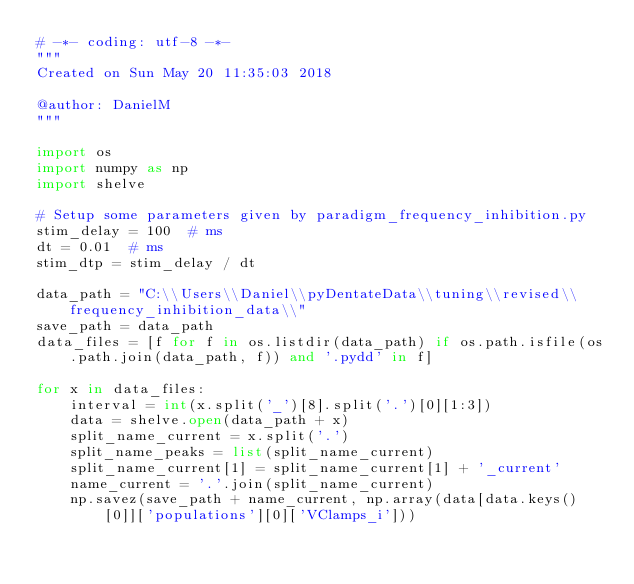Convert code to text. <code><loc_0><loc_0><loc_500><loc_500><_Python_># -*- coding: utf-8 -*-
"""
Created on Sun May 20 11:35:03 2018

@author: DanielM
"""

import os
import numpy as np
import shelve

# Setup some parameters given by paradigm_frequency_inhibition.py
stim_delay = 100  # ms
dt = 0.01  # ms
stim_dtp = stim_delay / dt

data_path = "C:\\Users\\Daniel\\pyDentateData\\tuning\\revised\\frequency_inhibition_data\\"
save_path = data_path
data_files = [f for f in os.listdir(data_path) if os.path.isfile(os.path.join(data_path, f)) and '.pydd' in f]

for x in data_files:
    interval = int(x.split('_')[8].split('.')[0][1:3])
    data = shelve.open(data_path + x)
    split_name_current = x.split('.')
    split_name_peaks = list(split_name_current)
    split_name_current[1] = split_name_current[1] + '_current'
    name_current = '.'.join(split_name_current)
    np.savez(save_path + name_current, np.array(data[data.keys()[0]]['populations'][0]['VClamps_i']))
</code> 